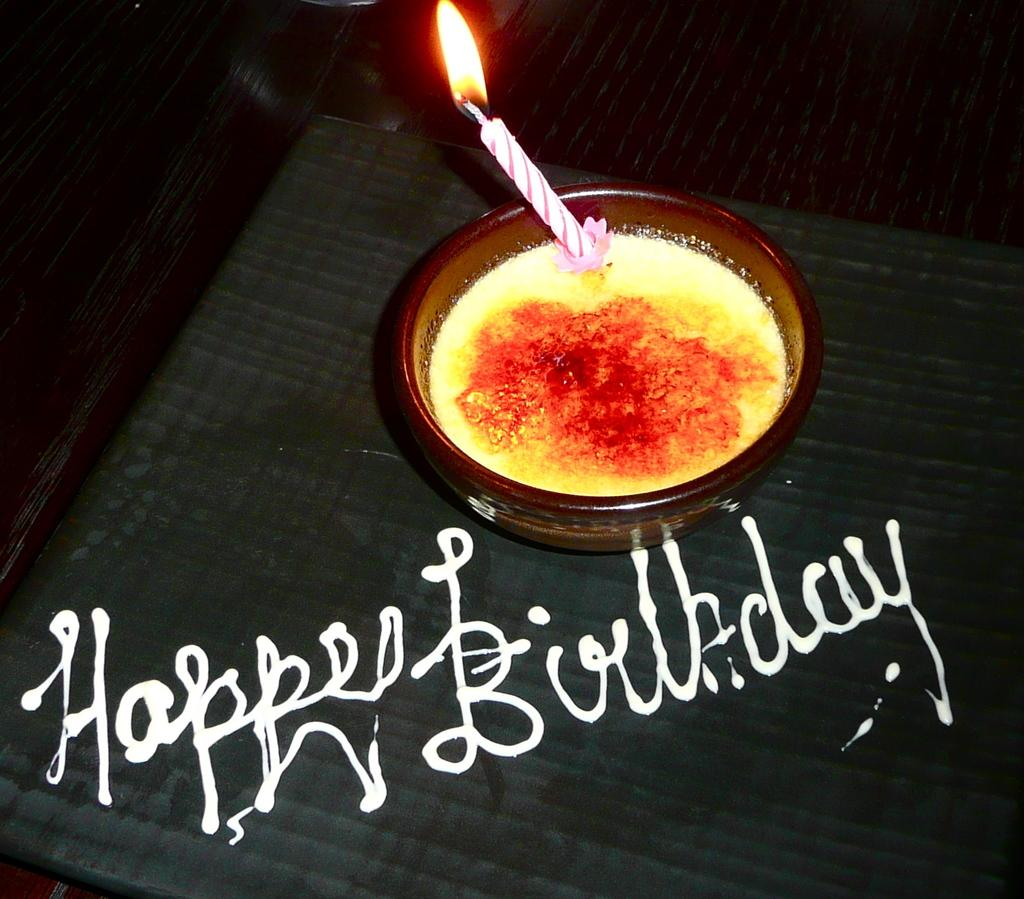What is in the bowl that is visible in the image? There is a bowl with some liquid in the image. What other object can be seen in the image? There is a candle with a flame in the image. Where are the candle and bowl located in the image? The candle and bowl are placed on a surface. What can be seen on the surface where the candle and bowl are placed? There is text visible on the surface. What type of beef is being cooked on the candle in the image? There is no beef present in the image; it features a candle with a flame and a bowl with liquid. What kind of view can be seen from the window in the image? There is no window present in the image, so it is not possible to determine the view. 